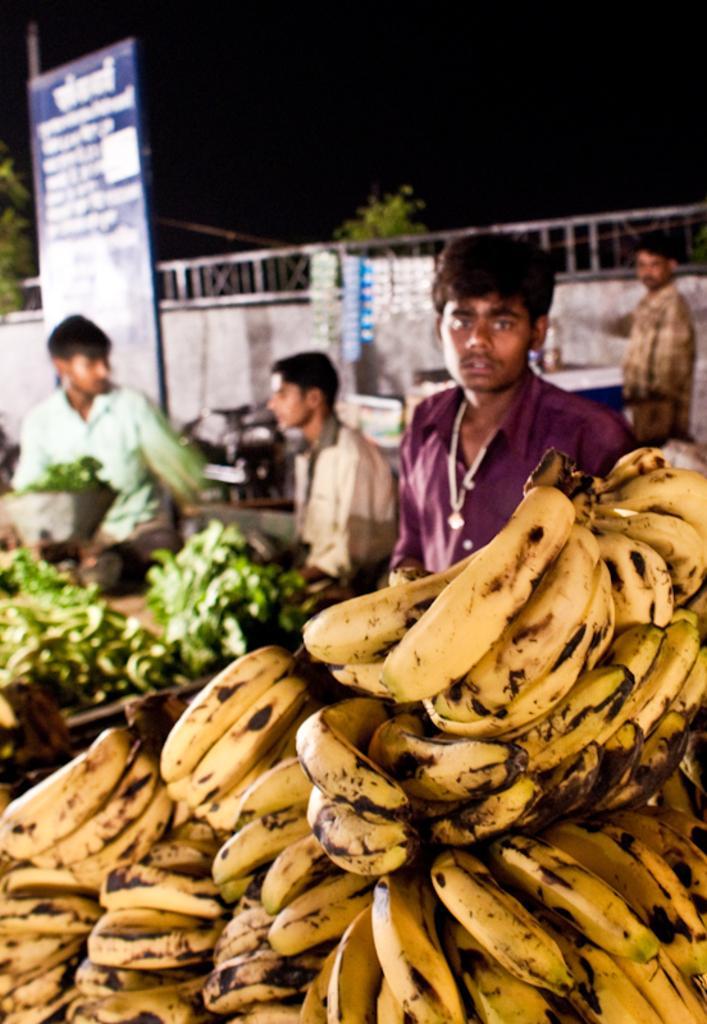Could you give a brief overview of what you see in this image? In this picture I can observe bananas. On the left side there are some leafy vegetables. There are some people in this picture. There is a board on the left side I can observe some text on the board. In the background there is a wall and I can observe sky which is dark. 